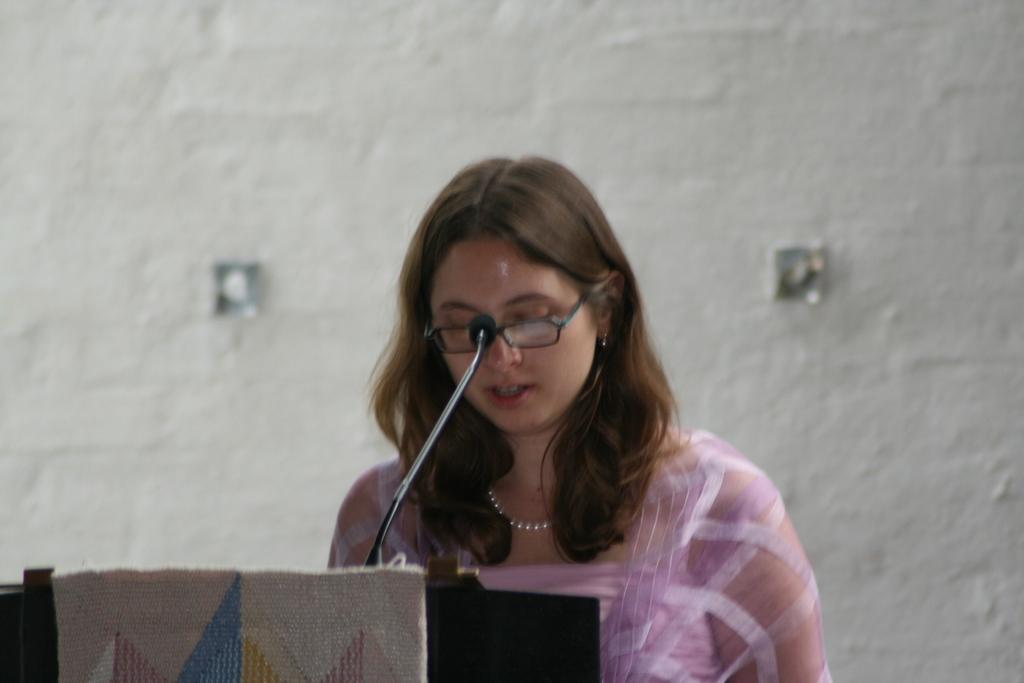What is the woman in the image wearing on her face? The woman in the image is wearing spectacles. What direction is the woman looking in the image? The woman is looking downwards. What object is in front of the woman in the image? There is a podium with a mic in front of the woman. What color is the background of the image? The background of the image is a white wall. What type of jam is the woman spreading on her shoe in the image? There is no jam or shoe present in the image; the woman is wearing spectacles and looking downwards in front of a podium with a mic. 